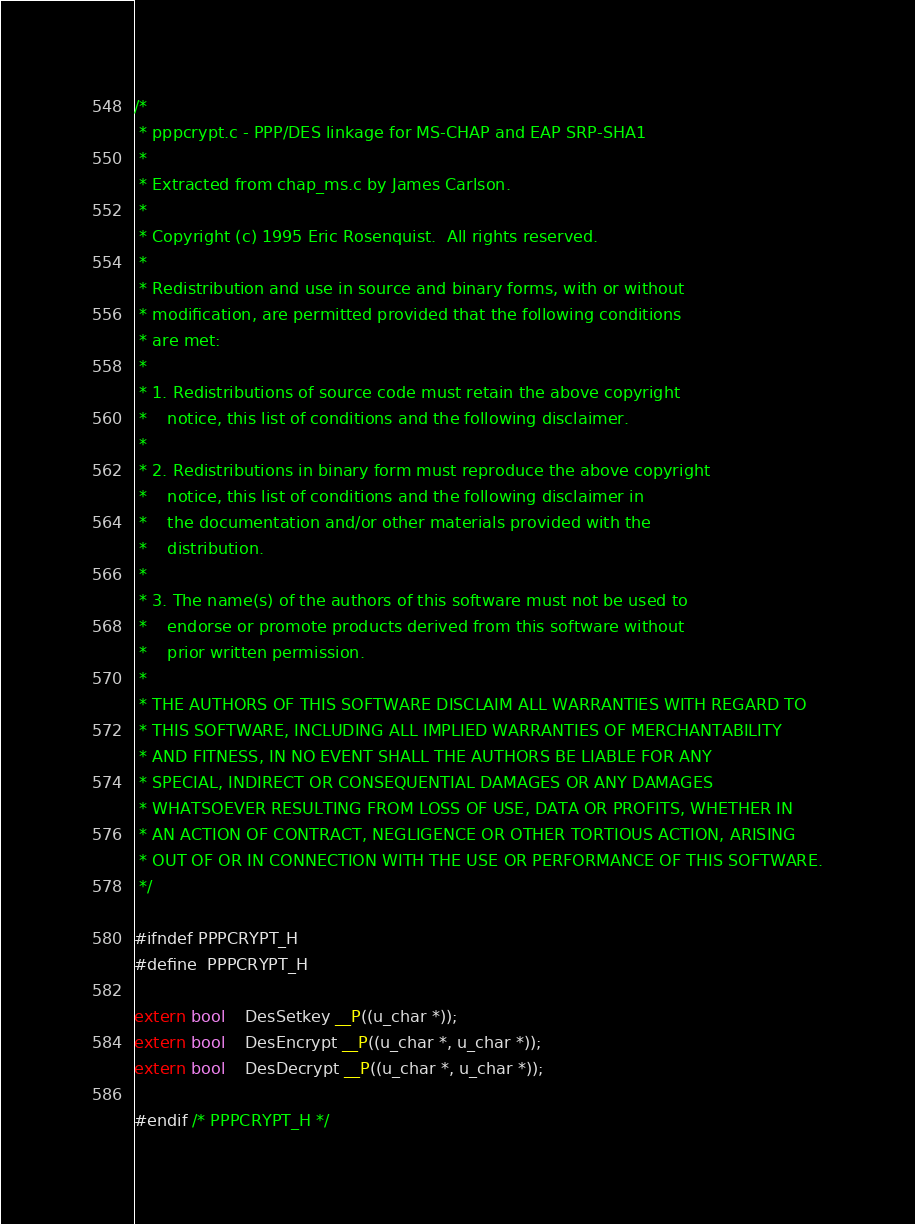<code> <loc_0><loc_0><loc_500><loc_500><_C_>/*
 * pppcrypt.c - PPP/DES linkage for MS-CHAP and EAP SRP-SHA1
 *
 * Extracted from chap_ms.c by James Carlson.
 *
 * Copyright (c) 1995 Eric Rosenquist.  All rights reserved.
 *
 * Redistribution and use in source and binary forms, with or without
 * modification, are permitted provided that the following conditions
 * are met:
 *
 * 1. Redistributions of source code must retain the above copyright
 *    notice, this list of conditions and the following disclaimer.
 *
 * 2. Redistributions in binary form must reproduce the above copyright
 *    notice, this list of conditions and the following disclaimer in
 *    the documentation and/or other materials provided with the
 *    distribution.
 *
 * 3. The name(s) of the authors of this software must not be used to
 *    endorse or promote products derived from this software without
 *    prior written permission.
 *
 * THE AUTHORS OF THIS SOFTWARE DISCLAIM ALL WARRANTIES WITH REGARD TO
 * THIS SOFTWARE, INCLUDING ALL IMPLIED WARRANTIES OF MERCHANTABILITY
 * AND FITNESS, IN NO EVENT SHALL THE AUTHORS BE LIABLE FOR ANY
 * SPECIAL, INDIRECT OR CONSEQUENTIAL DAMAGES OR ANY DAMAGES
 * WHATSOEVER RESULTING FROM LOSS OF USE, DATA OR PROFITS, WHETHER IN
 * AN ACTION OF CONTRACT, NEGLIGENCE OR OTHER TORTIOUS ACTION, ARISING
 * OUT OF OR IN CONNECTION WITH THE USE OR PERFORMANCE OF THIS SOFTWARE.
 */

#ifndef PPPCRYPT_H
#define	PPPCRYPT_H

extern bool	DesSetkey __P((u_char *));
extern bool	DesEncrypt __P((u_char *, u_char *));
extern bool	DesDecrypt __P((u_char *, u_char *));

#endif /* PPPCRYPT_H */
</code> 